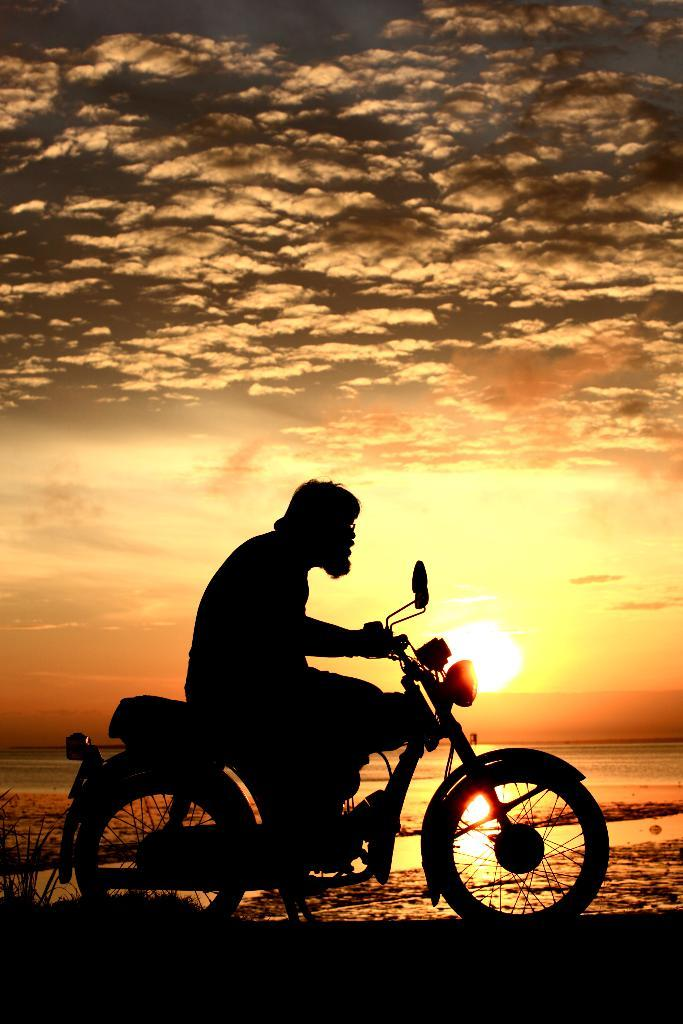What is the main subject of the image? There is a guy on a bike in the image. What can be seen in the sky in the image? The sky is visible in the image, and clouds are present. What is the background of the image? There is a sea in the background of the image. What is the position of the sun in the image? The sun is setting in the image. What type of orange is being used as a wrench by the beetle in the image? There are no oranges, beetles, or wrenches present in the image. 